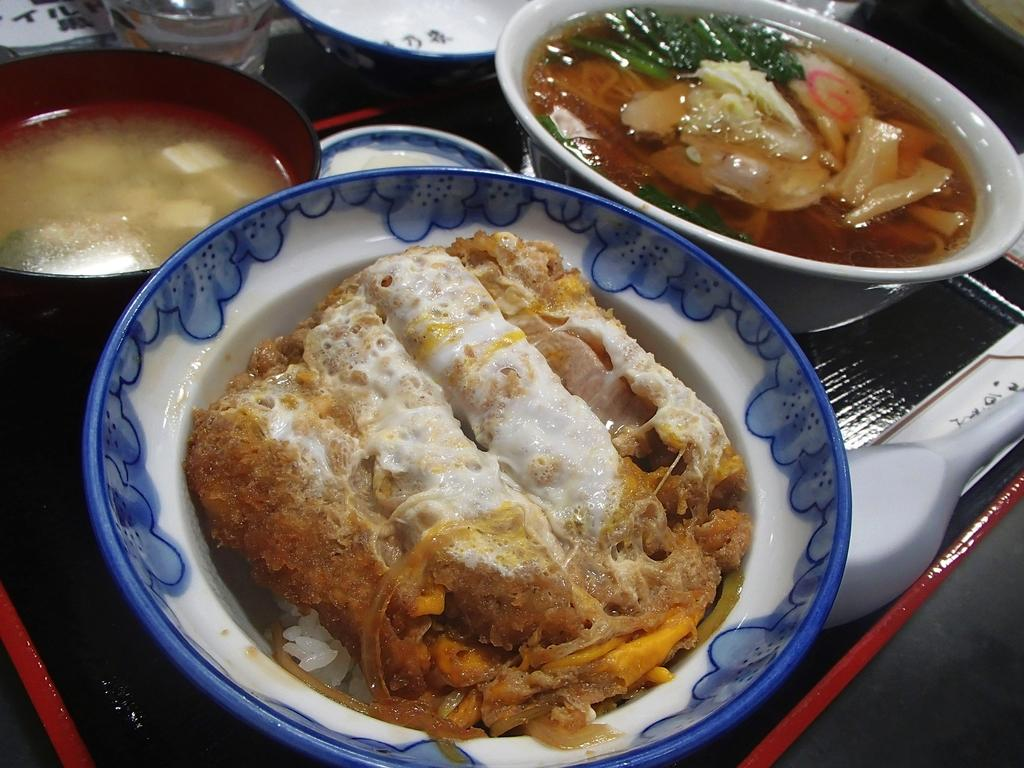What is the main subject of the image? The main subject of the image appears to be a tray. What can be found on the tray? There are bowls and a serving spoon on the tray. What is inside the bowls? The bowls contain different food items. How many rabbits can be seen on the tray in the image? There are no rabbits present in the image; it features a tray with bowls and a serving spoon. What type of fact can be learned about the lumber industry from the image? The image does not contain any information about the lumber industry, as it features a tray with bowls and a serving spoon. 